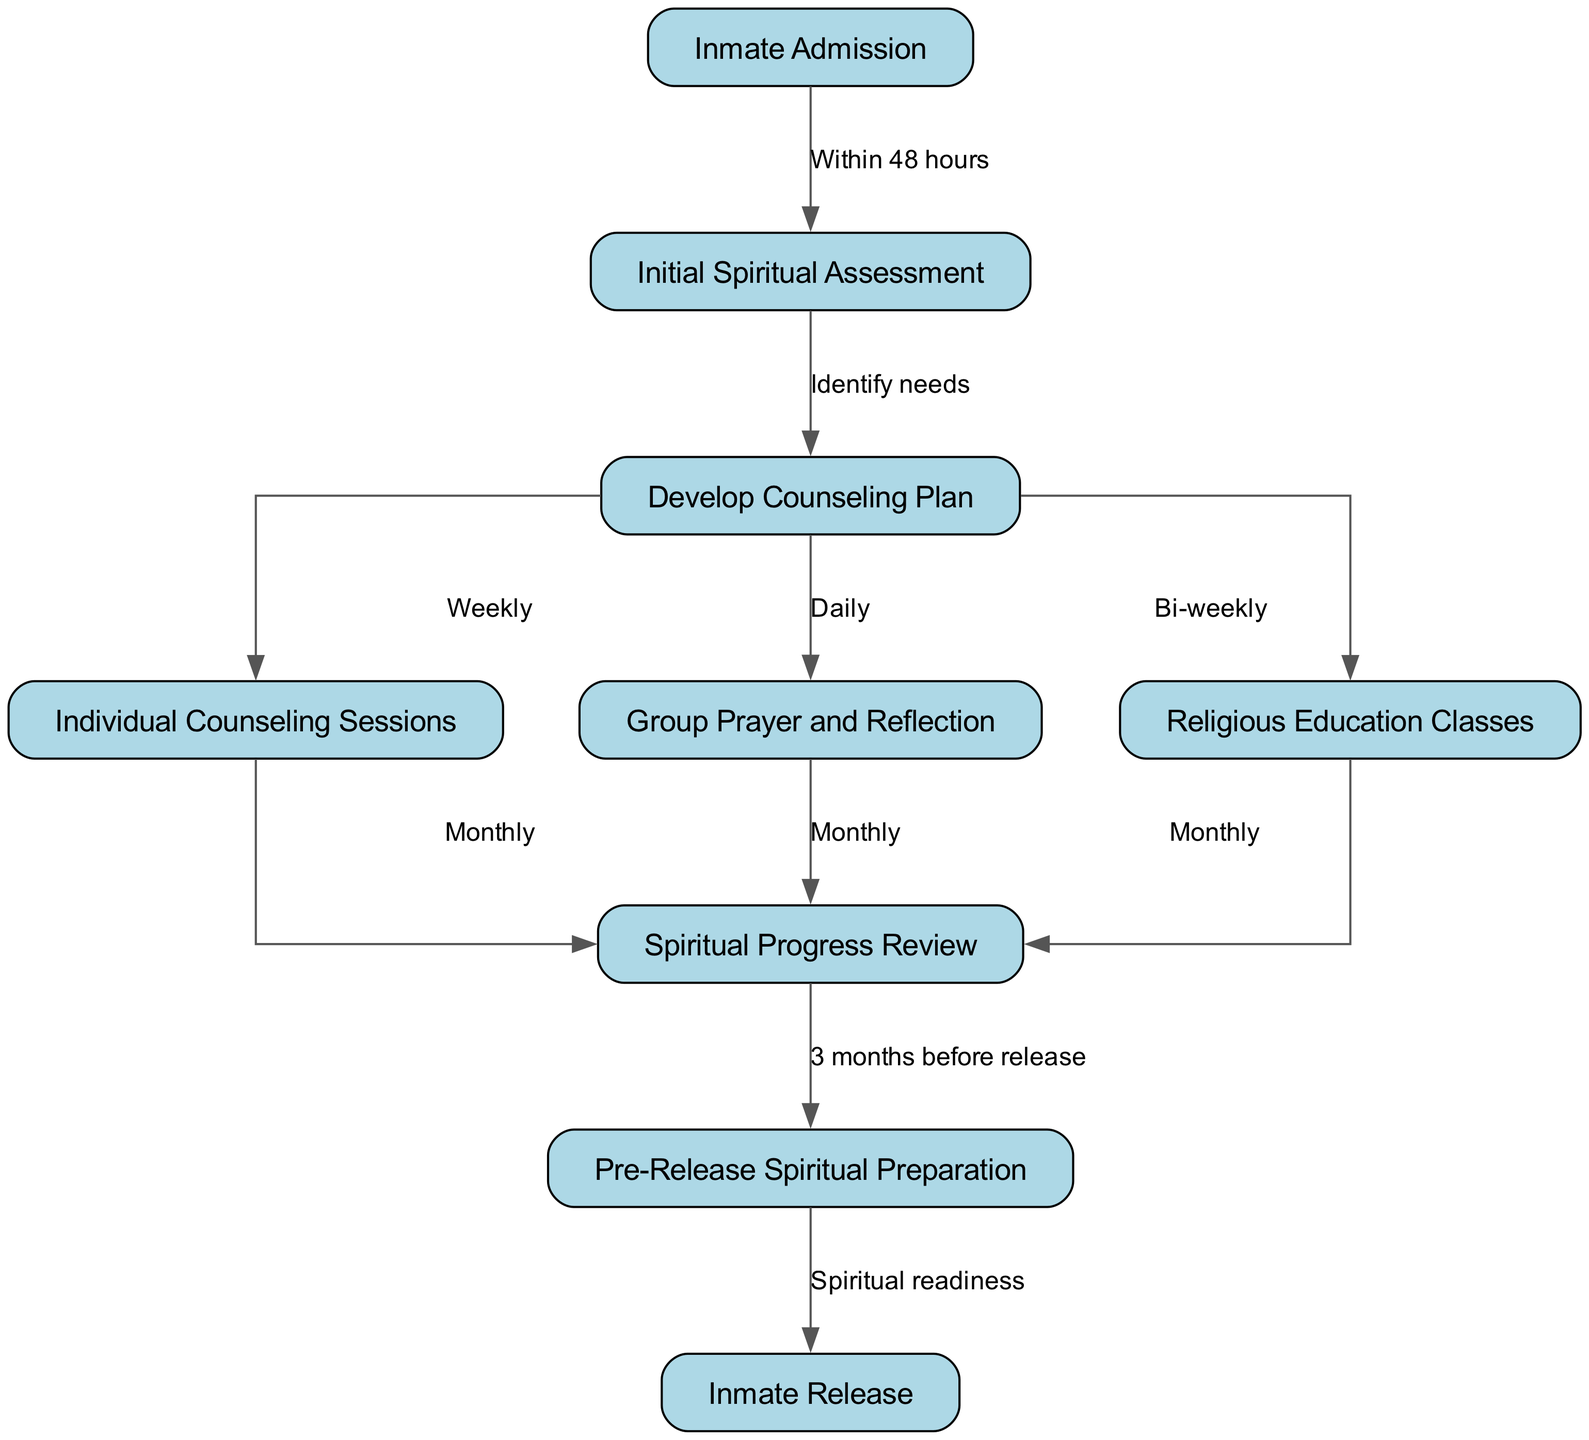What is the first step after inmate admission? The diagram indicates that the first step after "Inmate Admission" is "Initial Spiritual Assessment," which follows within 48 hours of admission.
Answer: Initial Spiritual Assessment How many counseling sessions are held weekly as per the diagram? The diagram specifies that "Individual Counseling Sessions" are scheduled weekly as part of the counseling plan.
Answer: Weekly What occurs three months before release? According to the diagram, "Spiritual Progress Review" transitions to "Pre-Release Spiritual Preparation" three months before the inmate's release.
Answer: Pre-Release Spiritual Preparation Which activities occur daily in the counseling plan? The diagram clearly shows that "Group Prayer and Reflection" occurs daily as part of the counseling plan.
Answer: Group Prayer and Reflection What is the sequence of events from the initial assessment to pre-release? Analyzing the diagram, the sequence starts with "Initial Spiritual Assessment," leads to "Develop Counseling Plan," followed by "Individual Counseling Sessions," "Group Prayer and Reflection," and culminates in "Spiritual Progress Review," which then transitions to "Pre-Release Spiritual Preparation."
Answer: Initial Spiritual Assessment, Develop Counseling Plan, Individual Counseling Sessions, Group Prayer and Reflection, Spiritual Progress Review, Pre-Release Spiritual Preparation How often are religious education classes conducted? The diagram outlines that "Religious Education Classes" are conducted bi-weekly as part of the counseling plan.
Answer: Bi-weekly What is needed for an inmate's release according to the diagram? The diagram states that "Spiritual readiness" is necessary for an inmate's release after going through the pre-release preparations.
Answer: Spiritual readiness What characterizes the relationship between progress review and individual sessions? The diagram illustrates that "Individual Counseling Sessions" and "Group Prayer" both lead to "Spiritual Progress Review," highlighting the ongoing assessment of progress through these sessions.
Answer: Both lead to Spiritual Progress Review How many nodes are in this clinical pathway diagram? Counting the nodes listed in the diagram, there are a total of nine distinct nodes that outline the spiritual counseling process.
Answer: Nine 